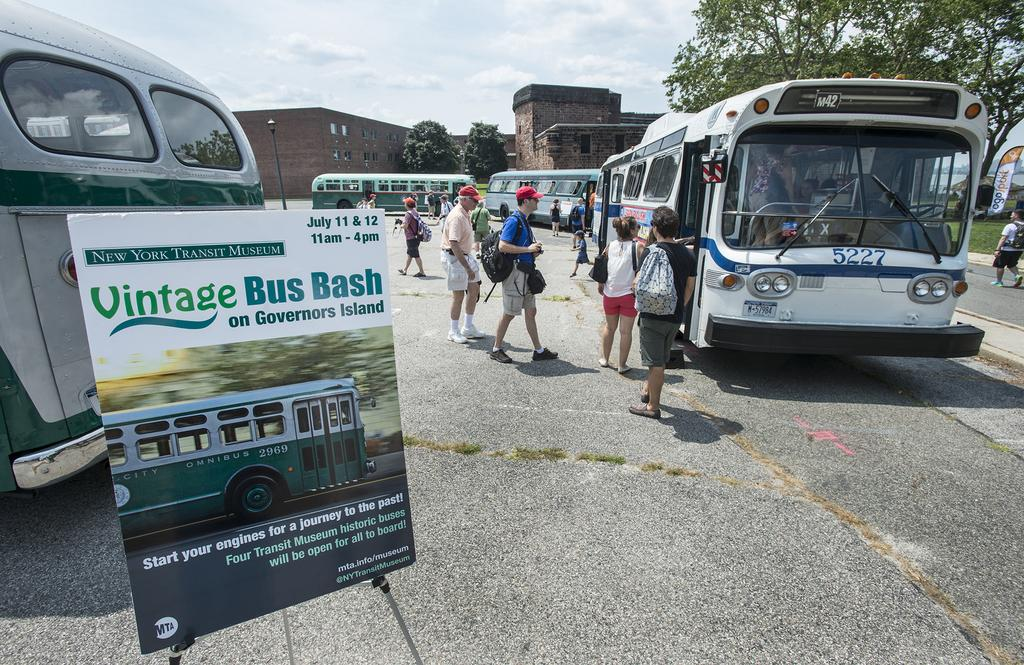What type of vehicles can be seen in the image? There are buses in the image. What else is present in the image besides the buses? There is a banner, people, a pole, and trees and buildings in the background of the image. What are the people wearing in the image? The people are wearing bags. What can be seen in the background of the image? Trees and buildings are present in the background of the image. What type of comfort can be found in the bear's den in the image? There is no bear or den present in the image. What is the purpose of the alarm in the image? There is no alarm present in the image. 